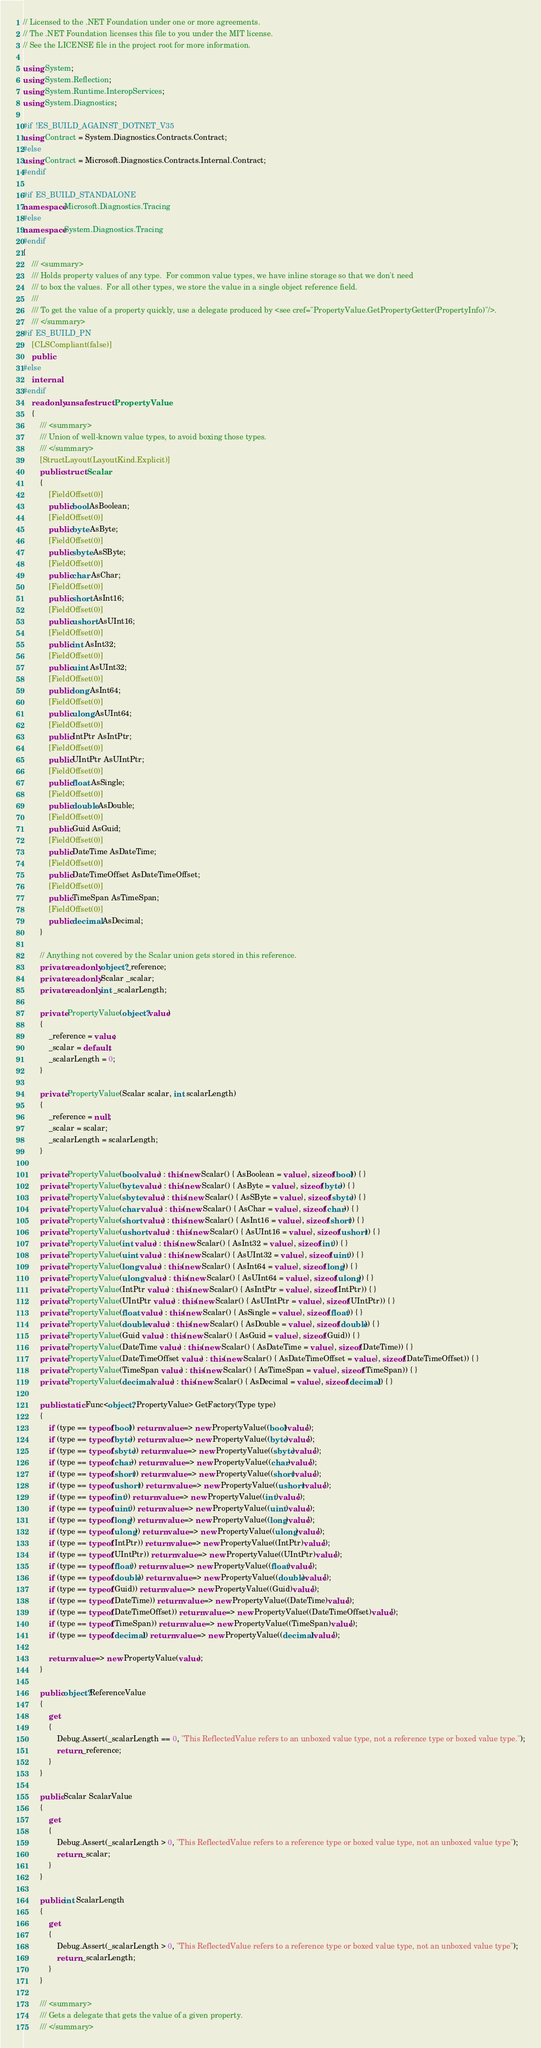Convert code to text. <code><loc_0><loc_0><loc_500><loc_500><_C#_>// Licensed to the .NET Foundation under one or more agreements.
// The .NET Foundation licenses this file to you under the MIT license.
// See the LICENSE file in the project root for more information.

using System;
using System.Reflection;
using System.Runtime.InteropServices;
using System.Diagnostics;

#if !ES_BUILD_AGAINST_DOTNET_V35
using Contract = System.Diagnostics.Contracts.Contract;
#else
using Contract = Microsoft.Diagnostics.Contracts.Internal.Contract;
#endif

#if ES_BUILD_STANDALONE
namespace Microsoft.Diagnostics.Tracing
#else
namespace System.Diagnostics.Tracing
#endif
{
    /// <summary>
    /// Holds property values of any type.  For common value types, we have inline storage so that we don't need
    /// to box the values.  For all other types, we store the value in a single object reference field.
    ///
    /// To get the value of a property quickly, use a delegate produced by <see cref="PropertyValue.GetPropertyGetter(PropertyInfo)"/>.
    /// </summary>
#if ES_BUILD_PN
    [CLSCompliant(false)]
    public
#else
    internal
#endif
    readonly unsafe struct PropertyValue
    {
        /// <summary>
        /// Union of well-known value types, to avoid boxing those types.
        /// </summary>
        [StructLayout(LayoutKind.Explicit)]
        public struct Scalar
        {
            [FieldOffset(0)]
            public bool AsBoolean;
            [FieldOffset(0)]
            public byte AsByte;
            [FieldOffset(0)]
            public sbyte AsSByte;
            [FieldOffset(0)]
            public char AsChar;
            [FieldOffset(0)]
            public short AsInt16;
            [FieldOffset(0)]
            public ushort AsUInt16;
            [FieldOffset(0)]
            public int AsInt32;
            [FieldOffset(0)]
            public uint AsUInt32;
            [FieldOffset(0)]
            public long AsInt64;
            [FieldOffset(0)]
            public ulong AsUInt64;
            [FieldOffset(0)]
            public IntPtr AsIntPtr;
            [FieldOffset(0)]
            public UIntPtr AsUIntPtr;
            [FieldOffset(0)]
            public float AsSingle;
            [FieldOffset(0)]
            public double AsDouble;
            [FieldOffset(0)]
            public Guid AsGuid;
            [FieldOffset(0)]
            public DateTime AsDateTime;
            [FieldOffset(0)]
            public DateTimeOffset AsDateTimeOffset;
            [FieldOffset(0)]
            public TimeSpan AsTimeSpan;
            [FieldOffset(0)]
            public decimal AsDecimal;
        }

        // Anything not covered by the Scalar union gets stored in this reference.
        private readonly object? _reference;
        private readonly Scalar _scalar;
        private readonly int _scalarLength;

        private PropertyValue(object? value)
        {
            _reference = value;
            _scalar = default;
            _scalarLength = 0;
        }

        private PropertyValue(Scalar scalar, int scalarLength)
        {
            _reference = null;
            _scalar = scalar;
            _scalarLength = scalarLength;
        }

        private PropertyValue(bool value) : this(new Scalar() { AsBoolean = value }, sizeof(bool)) { }
        private PropertyValue(byte value) : this(new Scalar() { AsByte = value }, sizeof(byte)) { }
        private PropertyValue(sbyte value) : this(new Scalar() { AsSByte = value }, sizeof(sbyte)) { }
        private PropertyValue(char value) : this(new Scalar() { AsChar = value }, sizeof(char)) { }
        private PropertyValue(short value) : this(new Scalar() { AsInt16 = value }, sizeof(short)) { }
        private PropertyValue(ushort value) : this(new Scalar() { AsUInt16 = value }, sizeof(ushort)) { }
        private PropertyValue(int value) : this(new Scalar() { AsInt32 = value }, sizeof(int)) { }
        private PropertyValue(uint value) : this(new Scalar() { AsUInt32 = value }, sizeof(uint)) { }
        private PropertyValue(long value) : this(new Scalar() { AsInt64 = value }, sizeof(long)) { }
        private PropertyValue(ulong value) : this(new Scalar() { AsUInt64 = value }, sizeof(ulong)) { }
        private PropertyValue(IntPtr value) : this(new Scalar() { AsIntPtr = value }, sizeof(IntPtr)) { }
        private PropertyValue(UIntPtr value) : this(new Scalar() { AsUIntPtr = value }, sizeof(UIntPtr)) { }
        private PropertyValue(float value) : this(new Scalar() { AsSingle = value }, sizeof(float)) { }
        private PropertyValue(double value) : this(new Scalar() { AsDouble = value }, sizeof(double)) { }
        private PropertyValue(Guid value) : this(new Scalar() { AsGuid = value }, sizeof(Guid)) { }
        private PropertyValue(DateTime value) : this(new Scalar() { AsDateTime = value }, sizeof(DateTime)) { }
        private PropertyValue(DateTimeOffset value) : this(new Scalar() { AsDateTimeOffset = value }, sizeof(DateTimeOffset)) { }
        private PropertyValue(TimeSpan value) : this(new Scalar() { AsTimeSpan = value }, sizeof(TimeSpan)) { }
        private PropertyValue(decimal value) : this(new Scalar() { AsDecimal = value }, sizeof(decimal)) { }

        public static Func<object?, PropertyValue> GetFactory(Type type)
        {
            if (type == typeof(bool)) return value => new PropertyValue((bool)value!);
            if (type == typeof(byte)) return value => new PropertyValue((byte)value!);
            if (type == typeof(sbyte)) return value => new PropertyValue((sbyte)value!);
            if (type == typeof(char)) return value => new PropertyValue((char)value!);
            if (type == typeof(short)) return value => new PropertyValue((short)value!);
            if (type == typeof(ushort)) return value => new PropertyValue((ushort)value!);
            if (type == typeof(int)) return value => new PropertyValue((int)value!);
            if (type == typeof(uint)) return value => new PropertyValue((uint)value!);
            if (type == typeof(long)) return value => new PropertyValue((long)value!);
            if (type == typeof(ulong)) return value => new PropertyValue((ulong)value!);
            if (type == typeof(IntPtr)) return value => new PropertyValue((IntPtr)value!);
            if (type == typeof(UIntPtr)) return value => new PropertyValue((UIntPtr)value!);
            if (type == typeof(float)) return value => new PropertyValue((float)value!);
            if (type == typeof(double)) return value => new PropertyValue((double)value!);
            if (type == typeof(Guid)) return value => new PropertyValue((Guid)value!);
            if (type == typeof(DateTime)) return value => new PropertyValue((DateTime)value!);
            if (type == typeof(DateTimeOffset)) return value => new PropertyValue((DateTimeOffset)value!);
            if (type == typeof(TimeSpan)) return value => new PropertyValue((TimeSpan)value!);
            if (type == typeof(decimal)) return value => new PropertyValue((decimal)value!);

            return value => new PropertyValue(value);
        }

        public object? ReferenceValue
        {
            get
            {
                Debug.Assert(_scalarLength == 0, "This ReflectedValue refers to an unboxed value type, not a reference type or boxed value type.");
                return _reference;
            }
        }

        public Scalar ScalarValue
        {
            get
            {
                Debug.Assert(_scalarLength > 0, "This ReflectedValue refers to a reference type or boxed value type, not an unboxed value type");
                return _scalar;
            }
        }

        public int ScalarLength
        {
            get
            {
                Debug.Assert(_scalarLength > 0, "This ReflectedValue refers to a reference type or boxed value type, not an unboxed value type");
                return _scalarLength;
            }
        }

        /// <summary>
        /// Gets a delegate that gets the value of a given property.
        /// </summary></code> 